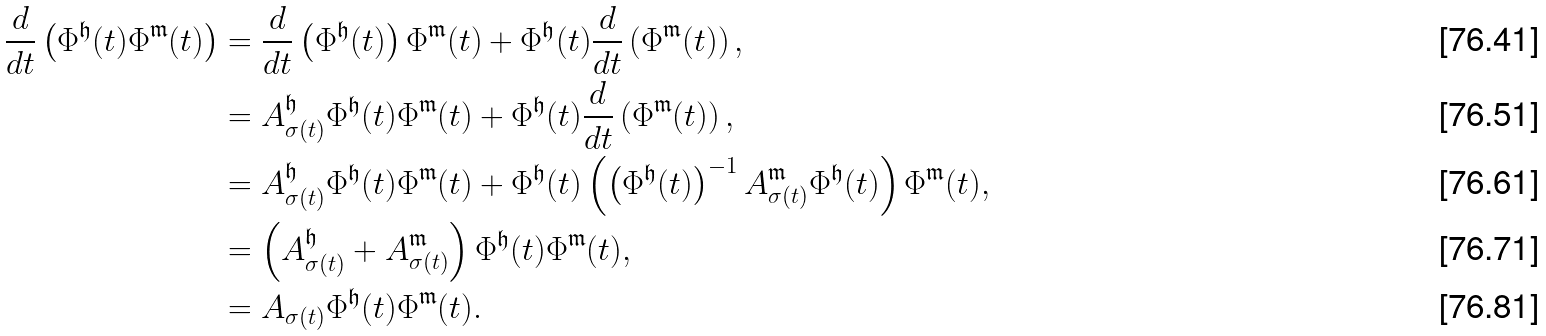<formula> <loc_0><loc_0><loc_500><loc_500>\frac { d } { d t } \left ( \Phi ^ { \mathfrak { h } } ( t ) \Phi ^ { \mathfrak { m } } ( t ) \right ) & = \frac { d } { d t } \left ( \Phi ^ { \mathfrak { h } } ( t ) \right ) \Phi ^ { \mathfrak { m } } ( t ) + \Phi ^ { \mathfrak { h } } ( t ) \frac { d } { d t } \left ( \Phi ^ { \mathfrak { m } } ( t ) \right ) , \\ & = A _ { \sigma ( t ) } ^ { \mathfrak { h } } \Phi ^ { \mathfrak { h } } ( t ) \Phi ^ { \mathfrak { m } } ( t ) + \Phi ^ { \mathfrak { h } } ( t ) \frac { d } { d t } \left ( \Phi ^ { \mathfrak { m } } ( t ) \right ) , \\ & = A _ { \sigma ( t ) } ^ { \mathfrak { h } } \Phi ^ { \mathfrak { h } } ( t ) \Phi ^ { \mathfrak { m } } ( t ) + \Phi ^ { \mathfrak { h } } ( t ) \left ( \left ( \Phi ^ { \mathfrak { h } } ( t ) \right ) ^ { - 1 } A _ { \sigma ( t ) } ^ { \mathfrak { m } } \Phi ^ { \mathfrak { h } } ( t ) \right ) \Phi ^ { \mathfrak { m } } ( t ) , \\ & = \left ( A _ { \sigma ( t ) } ^ { \mathfrak { h } } + A _ { \sigma ( t ) } ^ { \mathfrak { m } } \right ) \Phi ^ { \mathfrak { h } } ( t ) \Phi ^ { \mathfrak { m } } ( t ) , \\ & = A _ { \sigma ( t ) } \Phi ^ { \mathfrak { h } } ( t ) \Phi ^ { \mathfrak { m } } ( t ) .</formula> 